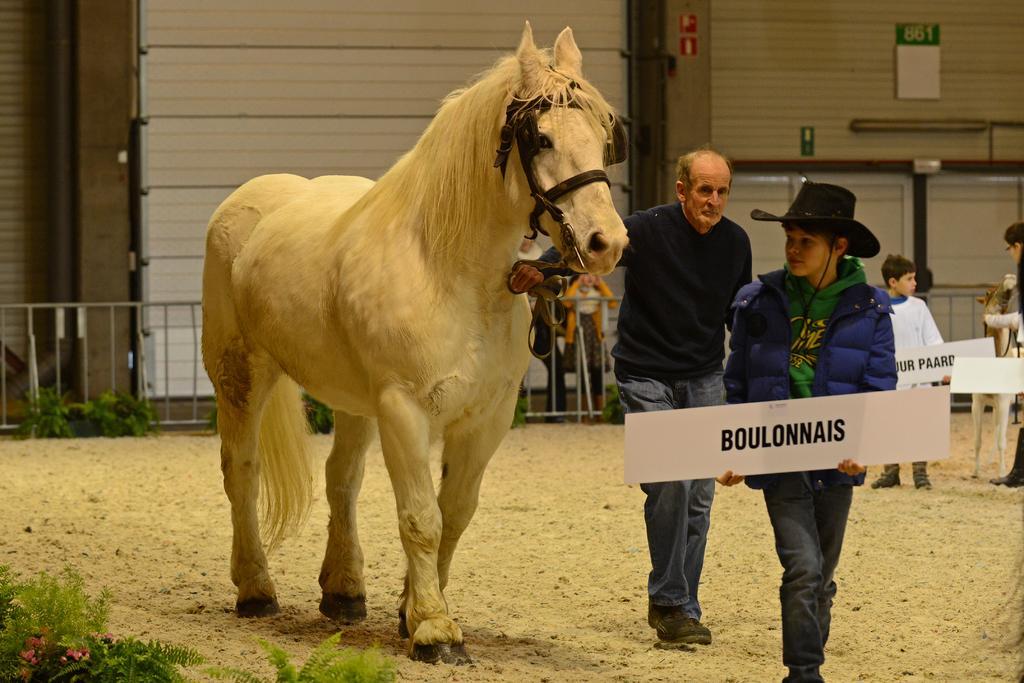Please provide a concise description of this image. In this picture we can see a horse in white colour. Near to it we can see two persons standing and on the background we can see sign boards and also few persons standing. At the left side of the picture we can see plants. This is a fence. 